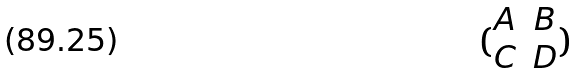Convert formula to latex. <formula><loc_0><loc_0><loc_500><loc_500>( \begin{matrix} A & B \\ C & D \end{matrix} )</formula> 